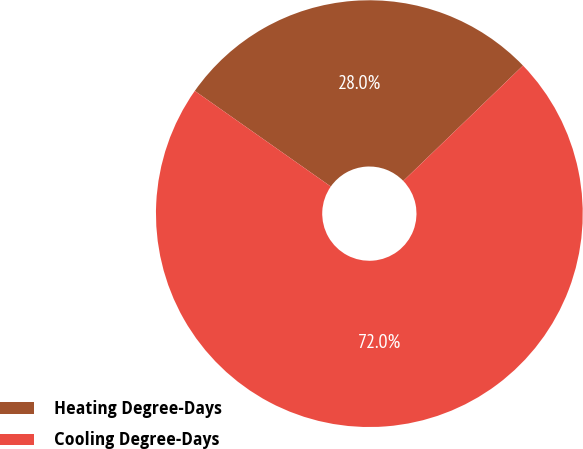Convert chart to OTSL. <chart><loc_0><loc_0><loc_500><loc_500><pie_chart><fcel>Heating Degree-Days<fcel>Cooling Degree-Days<nl><fcel>28.04%<fcel>71.96%<nl></chart> 